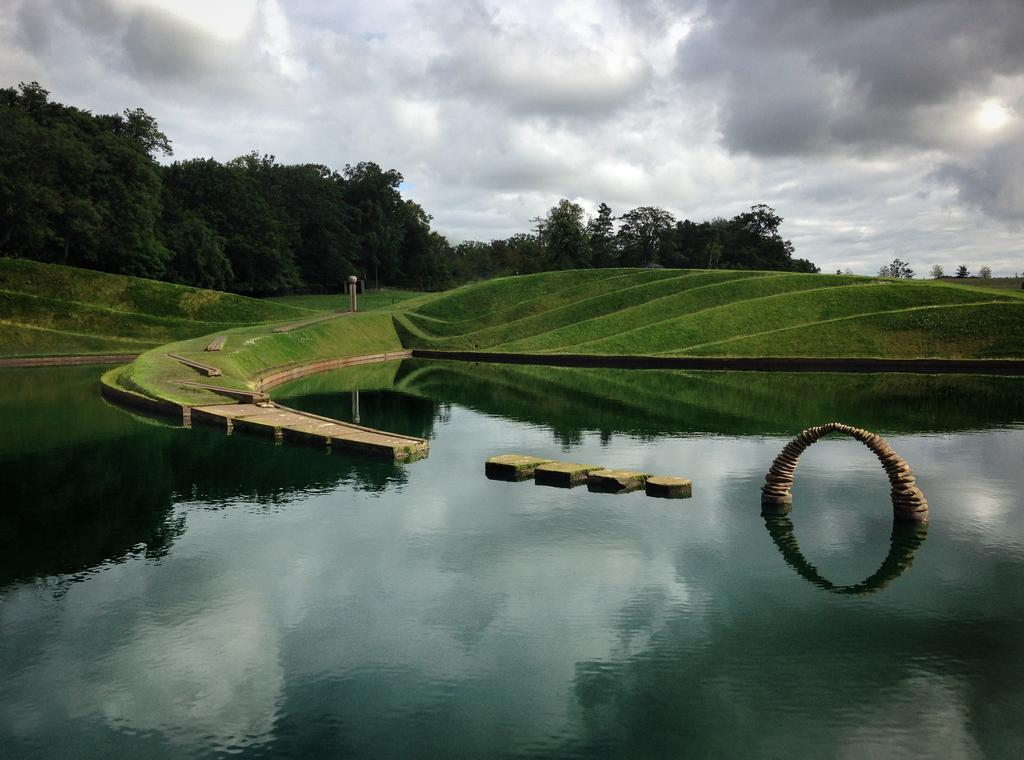What is the primary element in the image? There is water in the image. What type of vegetation can be seen in the image? There is grass visible in the image. What else is present in the image besides water and grass? There are objects in the image. What can be seen in the background of the image? There are trees and the sky visible in the background of the image. What type of silk fabric is draped over the trees in the image? There is no silk fabric present in the image; it features water, grass, objects, trees, and the sky. 